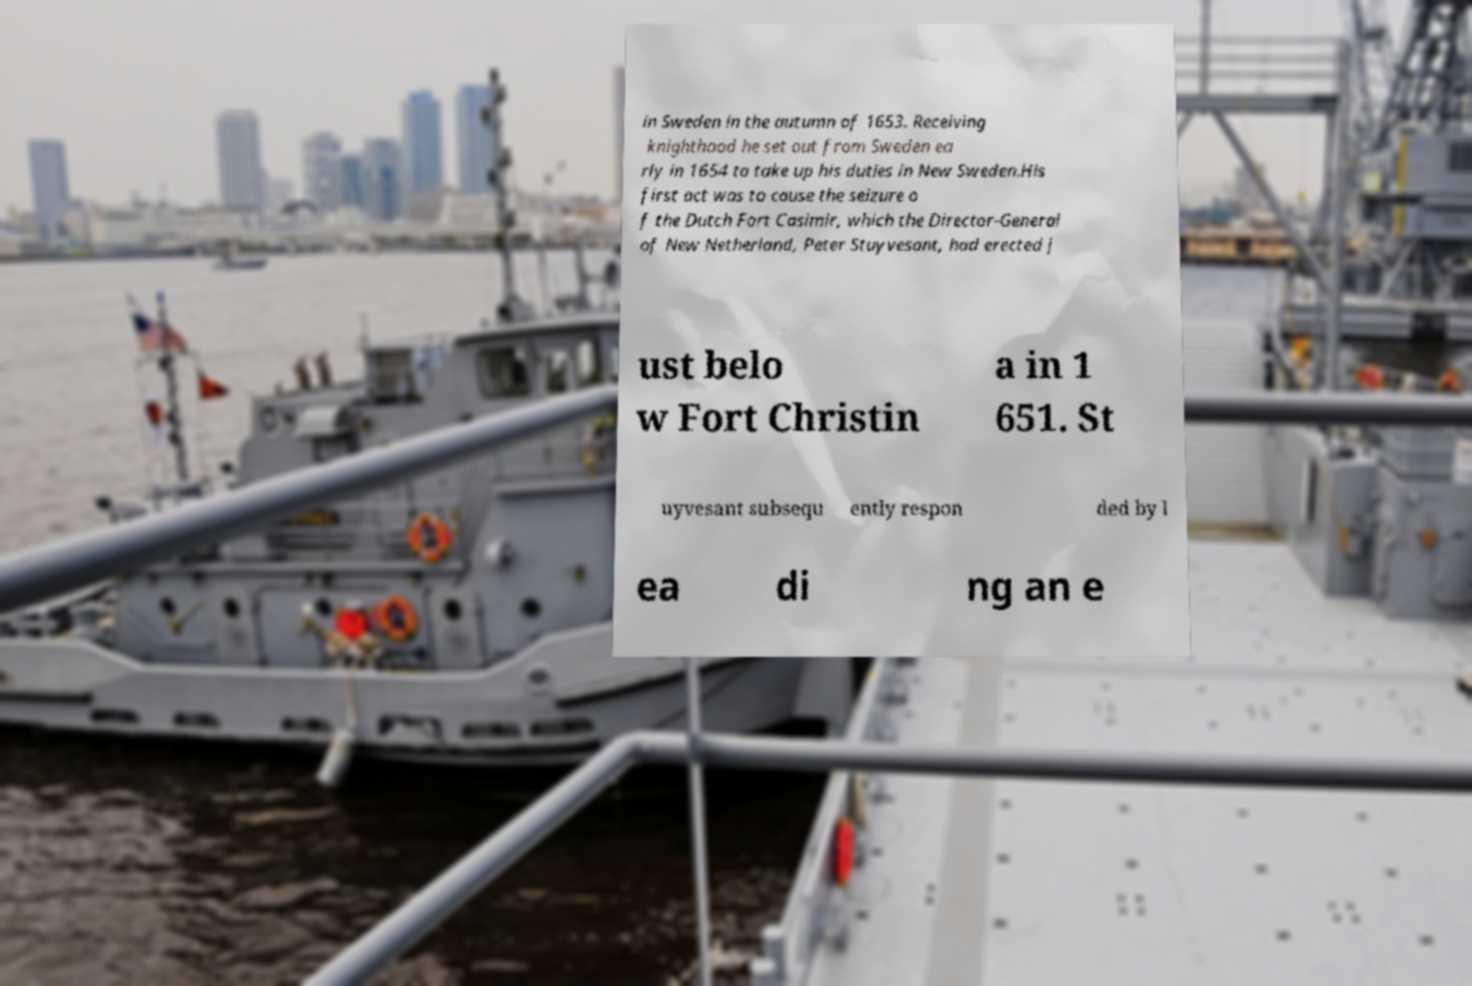Please read and relay the text visible in this image. What does it say? in Sweden in the autumn of 1653. Receiving knighthood he set out from Sweden ea rly in 1654 to take up his duties in New Sweden.His first act was to cause the seizure o f the Dutch Fort Casimir, which the Director-General of New Netherland, Peter Stuyvesant, had erected j ust belo w Fort Christin a in 1 651. St uyvesant subsequ ently respon ded by l ea di ng an e 